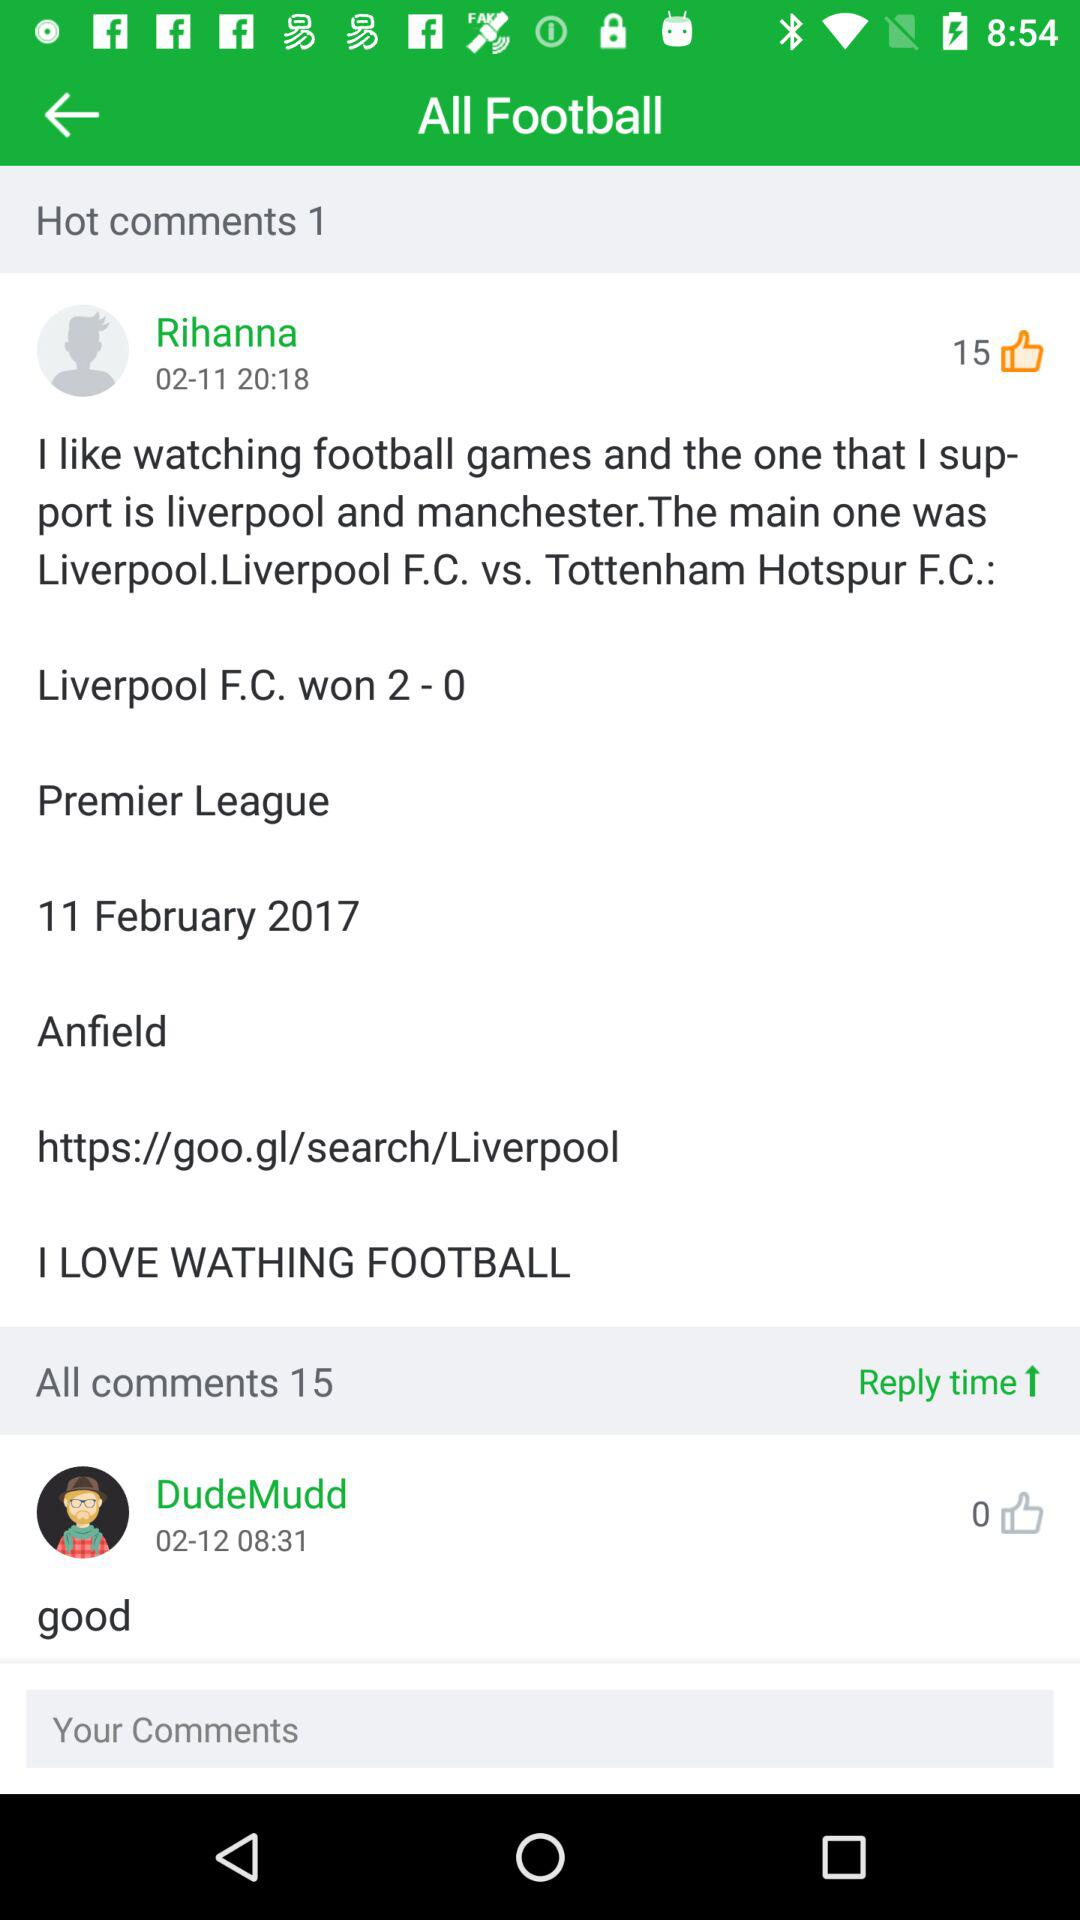How many likes are there for "DudeMudd"? There are 0 likes for "DudeMudd". 